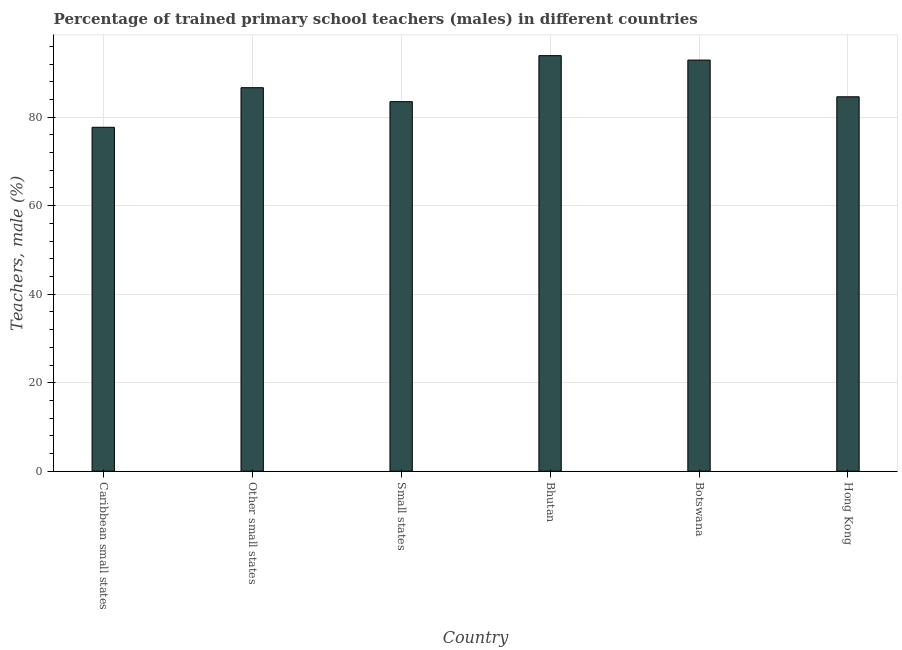Does the graph contain any zero values?
Provide a short and direct response. No. What is the title of the graph?
Provide a short and direct response. Percentage of trained primary school teachers (males) in different countries. What is the label or title of the Y-axis?
Ensure brevity in your answer.  Teachers, male (%). What is the percentage of trained male teachers in Bhutan?
Keep it short and to the point. 93.89. Across all countries, what is the maximum percentage of trained male teachers?
Keep it short and to the point. 93.89. Across all countries, what is the minimum percentage of trained male teachers?
Provide a short and direct response. 77.71. In which country was the percentage of trained male teachers maximum?
Offer a very short reply. Bhutan. In which country was the percentage of trained male teachers minimum?
Offer a terse response. Caribbean small states. What is the sum of the percentage of trained male teachers?
Provide a succinct answer. 519.25. What is the difference between the percentage of trained male teachers in Caribbean small states and Hong Kong?
Your answer should be very brief. -6.89. What is the average percentage of trained male teachers per country?
Your answer should be very brief. 86.54. What is the median percentage of trained male teachers?
Offer a very short reply. 85.63. What is the ratio of the percentage of trained male teachers in Botswana to that in Caribbean small states?
Ensure brevity in your answer.  1.2. Is the percentage of trained male teachers in Bhutan less than that in Caribbean small states?
Make the answer very short. No. What is the difference between the highest and the second highest percentage of trained male teachers?
Your response must be concise. 1. What is the difference between the highest and the lowest percentage of trained male teachers?
Your answer should be very brief. 16.18. In how many countries, is the percentage of trained male teachers greater than the average percentage of trained male teachers taken over all countries?
Your answer should be compact. 3. How many countries are there in the graph?
Give a very brief answer. 6. What is the difference between two consecutive major ticks on the Y-axis?
Give a very brief answer. 20. What is the Teachers, male (%) in Caribbean small states?
Offer a very short reply. 77.71. What is the Teachers, male (%) of Other small states?
Your answer should be very brief. 86.65. What is the Teachers, male (%) in Small states?
Ensure brevity in your answer.  83.5. What is the Teachers, male (%) in Bhutan?
Provide a short and direct response. 93.89. What is the Teachers, male (%) in Botswana?
Your response must be concise. 92.89. What is the Teachers, male (%) of Hong Kong?
Your response must be concise. 84.6. What is the difference between the Teachers, male (%) in Caribbean small states and Other small states?
Offer a very short reply. -8.94. What is the difference between the Teachers, male (%) in Caribbean small states and Small states?
Provide a short and direct response. -5.79. What is the difference between the Teachers, male (%) in Caribbean small states and Bhutan?
Offer a terse response. -16.18. What is the difference between the Teachers, male (%) in Caribbean small states and Botswana?
Give a very brief answer. -15.18. What is the difference between the Teachers, male (%) in Caribbean small states and Hong Kong?
Provide a short and direct response. -6.89. What is the difference between the Teachers, male (%) in Other small states and Small states?
Your answer should be very brief. 3.16. What is the difference between the Teachers, male (%) in Other small states and Bhutan?
Offer a terse response. -7.24. What is the difference between the Teachers, male (%) in Other small states and Botswana?
Ensure brevity in your answer.  -6.24. What is the difference between the Teachers, male (%) in Other small states and Hong Kong?
Offer a terse response. 2.05. What is the difference between the Teachers, male (%) in Small states and Bhutan?
Ensure brevity in your answer.  -10.4. What is the difference between the Teachers, male (%) in Small states and Botswana?
Provide a short and direct response. -9.4. What is the difference between the Teachers, male (%) in Small states and Hong Kong?
Make the answer very short. -1.1. What is the difference between the Teachers, male (%) in Bhutan and Botswana?
Keep it short and to the point. 1. What is the difference between the Teachers, male (%) in Bhutan and Hong Kong?
Provide a succinct answer. 9.29. What is the difference between the Teachers, male (%) in Botswana and Hong Kong?
Your answer should be compact. 8.29. What is the ratio of the Teachers, male (%) in Caribbean small states to that in Other small states?
Keep it short and to the point. 0.9. What is the ratio of the Teachers, male (%) in Caribbean small states to that in Bhutan?
Make the answer very short. 0.83. What is the ratio of the Teachers, male (%) in Caribbean small states to that in Botswana?
Keep it short and to the point. 0.84. What is the ratio of the Teachers, male (%) in Caribbean small states to that in Hong Kong?
Keep it short and to the point. 0.92. What is the ratio of the Teachers, male (%) in Other small states to that in Small states?
Make the answer very short. 1.04. What is the ratio of the Teachers, male (%) in Other small states to that in Bhutan?
Keep it short and to the point. 0.92. What is the ratio of the Teachers, male (%) in Other small states to that in Botswana?
Offer a very short reply. 0.93. What is the ratio of the Teachers, male (%) in Small states to that in Bhutan?
Provide a succinct answer. 0.89. What is the ratio of the Teachers, male (%) in Small states to that in Botswana?
Provide a succinct answer. 0.9. What is the ratio of the Teachers, male (%) in Small states to that in Hong Kong?
Offer a very short reply. 0.99. What is the ratio of the Teachers, male (%) in Bhutan to that in Hong Kong?
Provide a succinct answer. 1.11. What is the ratio of the Teachers, male (%) in Botswana to that in Hong Kong?
Ensure brevity in your answer.  1.1. 